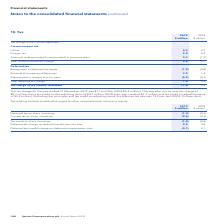According to Spirent Communications Plc's financial document, What was the tax charge for the year ended 31 December 2019? According to the financial document, $11.6 million. The relevant text states: "tax charge for the year ended 31 December 2019 was $11.6 million (2018 $5.4 million). This was after a prior year tax charge of $0.1 million and a tax credit on the..." Also, What was the effective tax rate excluding the prior year and tax credit on adjusting items? According to the financial document, 13.0 per cent. The relevant text states: "it on adjusting items, the effective tax rate was 13.0 per cent (2018 15.4 per cent)...." Also, Which are the broad categories of tax considered in the tax charge in the income statement? The document shows two values: Current income tax and Deferred tax. From the document: "Current income tax Deferred tax..." Additionally, In which year was the UK tax larger? According to the financial document, 2019. The relevant text states: "140 Spirent Communications plc Annual Report 2019..." Also, can you calculate: What was the change in the tax charge in the income statement? Based on the calculation: 11.6-5.4, the result is 6.2 (in millions). This is based on the information: "Tax charge in the income statement 11.6 5.4 Tax charge in the income statement 11.6 5.4..." The key data points involved are: 11.6, 5.4. Also, can you calculate: What was the percentage change in the tax charge in the income statement? To answer this question, I need to perform calculations using the financial data. The calculation is: (11.6-5.4)/5.4, which equals 114.81 (percentage). This is based on the information: "Tax charge in the income statement 11.6 5.4 Tax charge in the income statement 11.6 5.4..." The key data points involved are: 11.6, 5.4. 